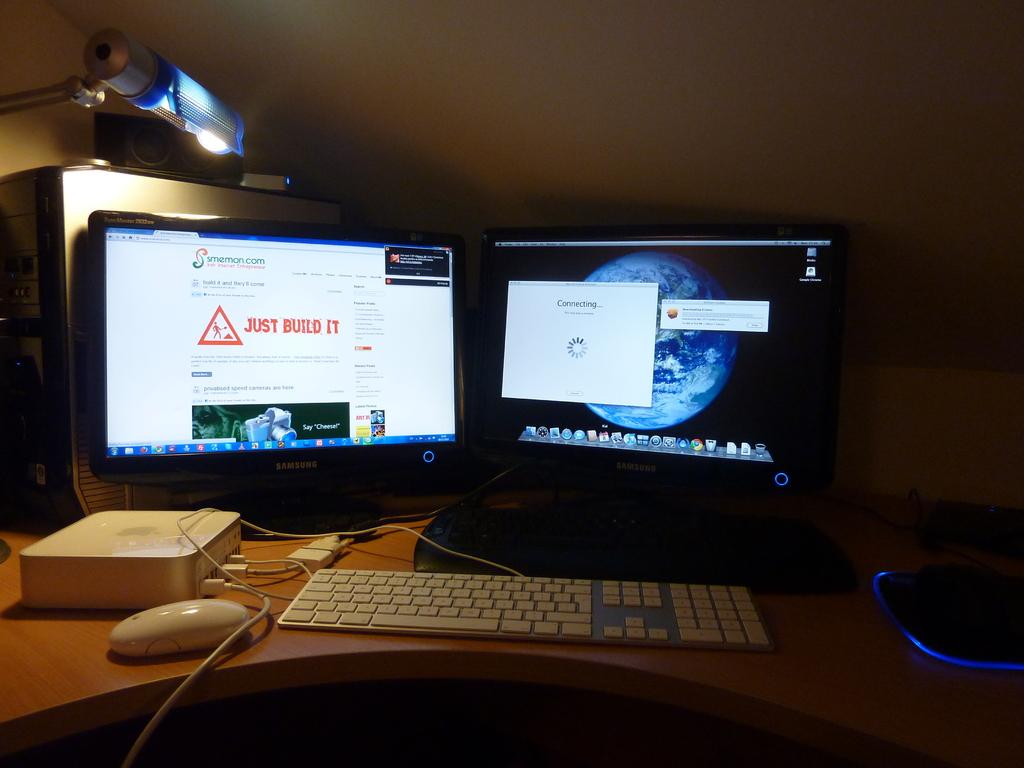<image>
Share a concise interpretation of the image provided. Two computer monitors are on and one says, "Just Build it" in red. 